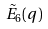<formula> <loc_0><loc_0><loc_500><loc_500>\tilde { E } _ { 6 } ( q )</formula> 